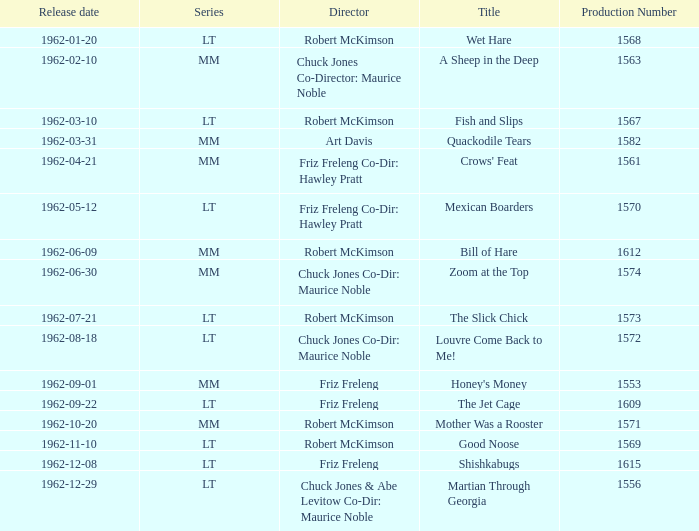What is the title of the film with production number 1553, directed by Friz Freleng? Honey's Money. 